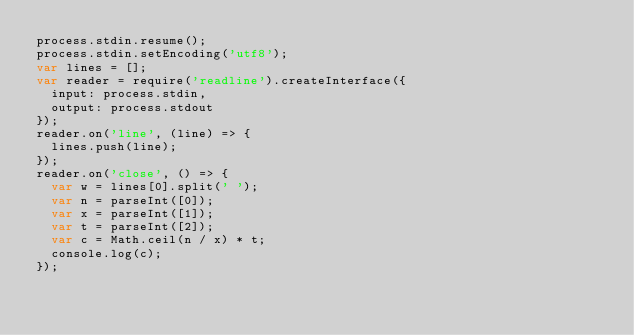Convert code to text. <code><loc_0><loc_0><loc_500><loc_500><_JavaScript_>process.stdin.resume();
process.stdin.setEncoding('utf8');
var lines = [];
var reader = require('readline').createInterface({
  input: process.stdin,
  output: process.stdout
});
reader.on('line', (line) => {
  lines.push(line);
});
reader.on('close', () => {
  var w = lines[0].split(' ');
  var n = parseInt([0]);
  var x = parseInt([1]);
  var t = parseInt([2]);
  var c = Math.ceil(n / x) * t;
  console.log(c);
});</code> 